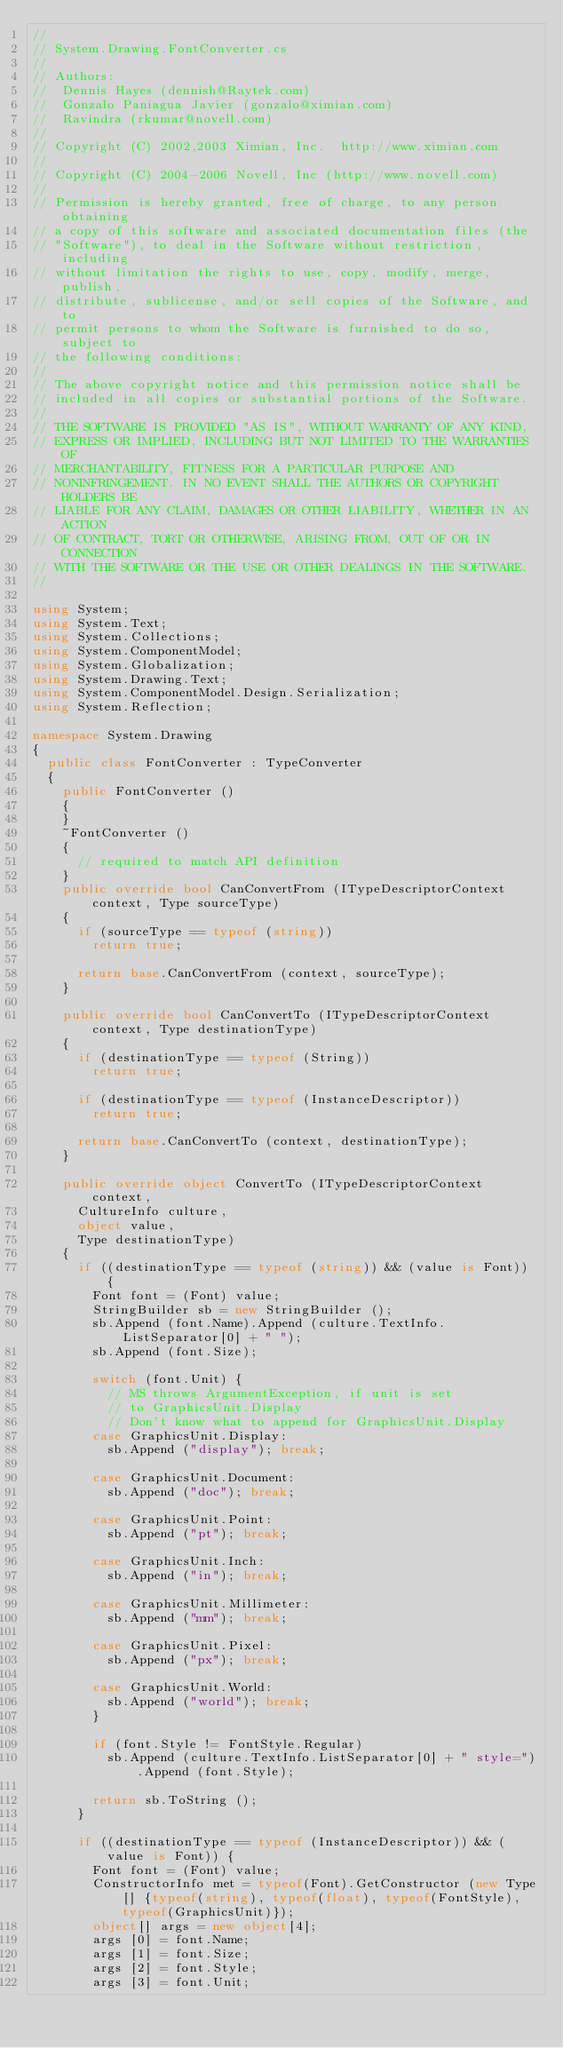Convert code to text. <code><loc_0><loc_0><loc_500><loc_500><_C#_>//
// System.Drawing.FontConverter.cs
//
// Authors:
//	Dennis Hayes (dennish@Raytek.com)
//	Gonzalo Paniagua Javier (gonzalo@ximian.com)
//	Ravindra (rkumar@novell.com)
//
// Copyright (C) 2002,2003 Ximian, Inc.  http://www.ximian.com
//
// Copyright (C) 2004-2006 Novell, Inc (http://www.novell.com)
//
// Permission is hereby granted, free of charge, to any person obtaining
// a copy of this software and associated documentation files (the
// "Software"), to deal in the Software without restriction, including
// without limitation the rights to use, copy, modify, merge, publish,
// distribute, sublicense, and/or sell copies of the Software, and to
// permit persons to whom the Software is furnished to do so, subject to
// the following conditions:
// 
// The above copyright notice and this permission notice shall be
// included in all copies or substantial portions of the Software.
// 
// THE SOFTWARE IS PROVIDED "AS IS", WITHOUT WARRANTY OF ANY KIND,
// EXPRESS OR IMPLIED, INCLUDING BUT NOT LIMITED TO THE WARRANTIES OF
// MERCHANTABILITY, FITNESS FOR A PARTICULAR PURPOSE AND
// NONINFRINGEMENT. IN NO EVENT SHALL THE AUTHORS OR COPYRIGHT HOLDERS BE
// LIABLE FOR ANY CLAIM, DAMAGES OR OTHER LIABILITY, WHETHER IN AN ACTION
// OF CONTRACT, TORT OR OTHERWISE, ARISING FROM, OUT OF OR IN CONNECTION
// WITH THE SOFTWARE OR THE USE OR OTHER DEALINGS IN THE SOFTWARE.
//

using System;
using System.Text;
using System.Collections;
using System.ComponentModel;
using System.Globalization;
using System.Drawing.Text;
using System.ComponentModel.Design.Serialization;
using System.Reflection;

namespace System.Drawing
{
	public class FontConverter : TypeConverter
	{
		public FontConverter ()
		{
		}
		~FontConverter ()
		{
			// required to match API definition
		}	
		public override bool CanConvertFrom (ITypeDescriptorContext context, Type sourceType)
		{
			if (sourceType == typeof (string))
				return true;

			return base.CanConvertFrom (context, sourceType);
		}

		public override bool CanConvertTo (ITypeDescriptorContext context, Type destinationType)
		{
			if (destinationType == typeof (String))
				return true;

			if (destinationType == typeof (InstanceDescriptor))
				return true;

			return base.CanConvertTo (context, destinationType);
		}

		public override object ConvertTo (ITypeDescriptorContext context,
			CultureInfo culture,
			object value,
			Type destinationType)
		{
			if ((destinationType == typeof (string)) && (value is Font)) {
				Font font = (Font) value;
				StringBuilder sb = new StringBuilder ();
				sb.Append (font.Name).Append (culture.TextInfo.ListSeparator[0] + " ");
				sb.Append (font.Size);

				switch (font.Unit) {
					// MS throws ArgumentException, if unit is set 
					// to GraphicsUnit.Display
					// Don't know what to append for GraphicsUnit.Display
				case GraphicsUnit.Display:
					sb.Append ("display"); break;

				case GraphicsUnit.Document:
					sb.Append ("doc"); break;

				case GraphicsUnit.Point:
					sb.Append ("pt"); break;

				case GraphicsUnit.Inch:
					sb.Append ("in"); break;

				case GraphicsUnit.Millimeter:
					sb.Append ("mm"); break;

				case GraphicsUnit.Pixel:
					sb.Append ("px"); break;

				case GraphicsUnit.World:
					sb.Append ("world"); break;
				}

				if (font.Style != FontStyle.Regular)
					sb.Append (culture.TextInfo.ListSeparator[0] + " style=").Append (font.Style);

				return sb.ToString ();
			}

			if ((destinationType == typeof (InstanceDescriptor)) && (value is Font)) {
				Font font = (Font) value;
				ConstructorInfo met = typeof(Font).GetConstructor (new Type[] {typeof(string), typeof(float), typeof(FontStyle), typeof(GraphicsUnit)});
				object[] args = new object[4];
				args [0] = font.Name;
				args [1] = font.Size;
				args [2] = font.Style;
				args [3] = font.Unit;</code> 